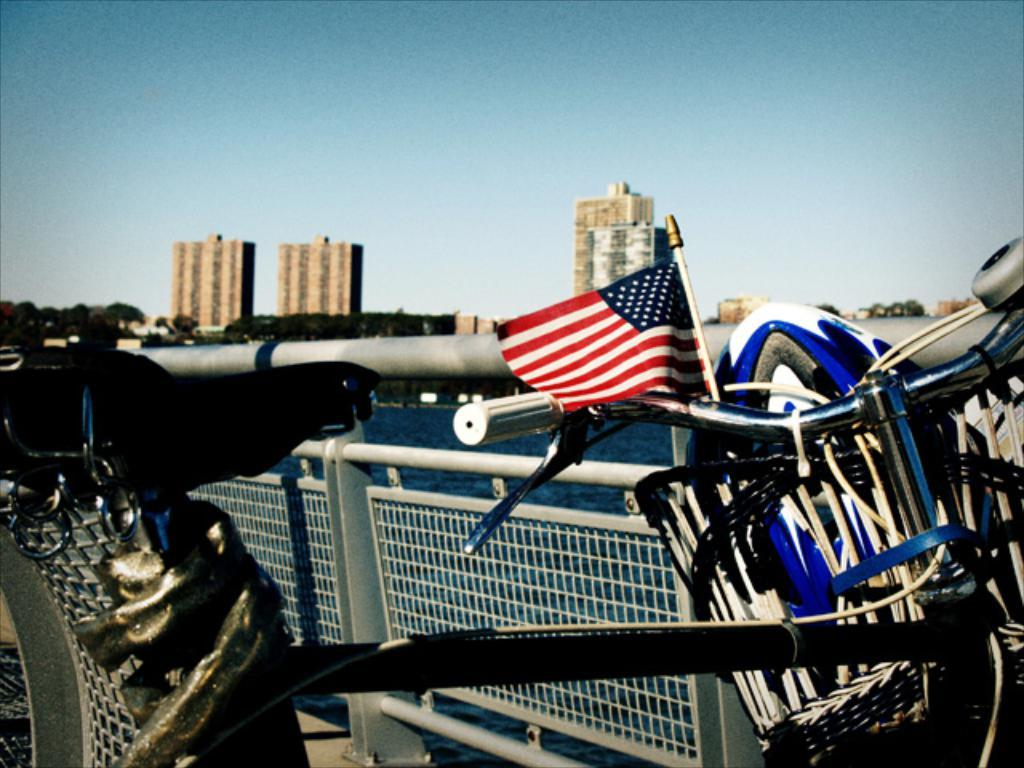What is the main object in the picture? There is a bicycle in the picture. What else can be seen in the picture besides the bicycle? There is a flag, a helmet in a basket on the bicycle, iron grills, water, trees, buildings, and the sky visible in the background of the picture. What type of hair is visible on the throne in the picture? There is no throne present in the image, so there is no hair to be observed. 